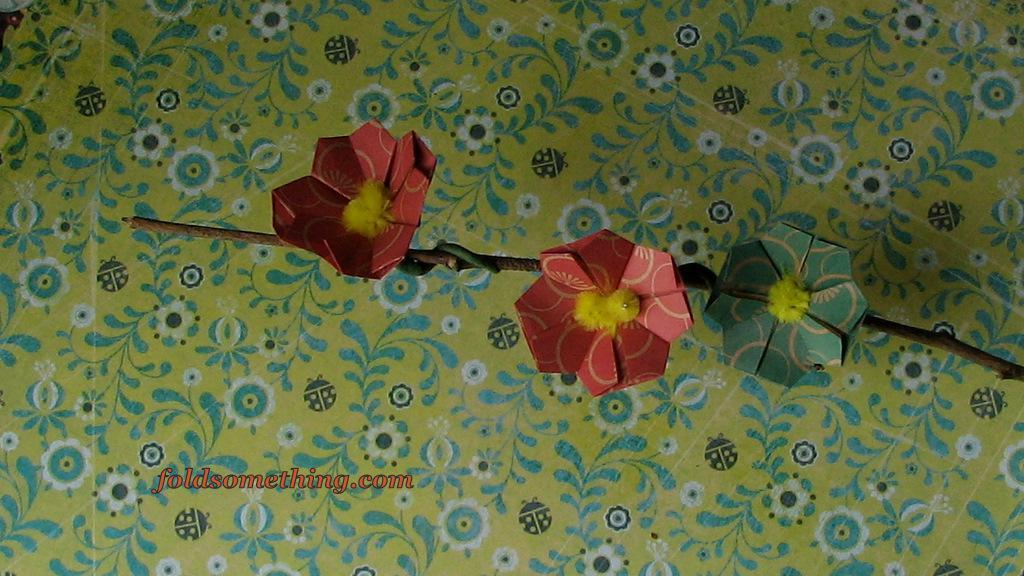How many paper flowers are in the image? There are three paper flowers in the image. What colors are the paper flowers? The paper flowers are in red, yellow, and green colors. What can be seen in the background of the image? There is a colorful cloth in the background of the image. Are there any snakes visible in the image? No, there are no snakes present in the image. What type of ornament is hanging from the ceiling in the image? There is no ornament hanging from the ceiling in the image; it only features paper flowers and a colorful cloth in the background. 